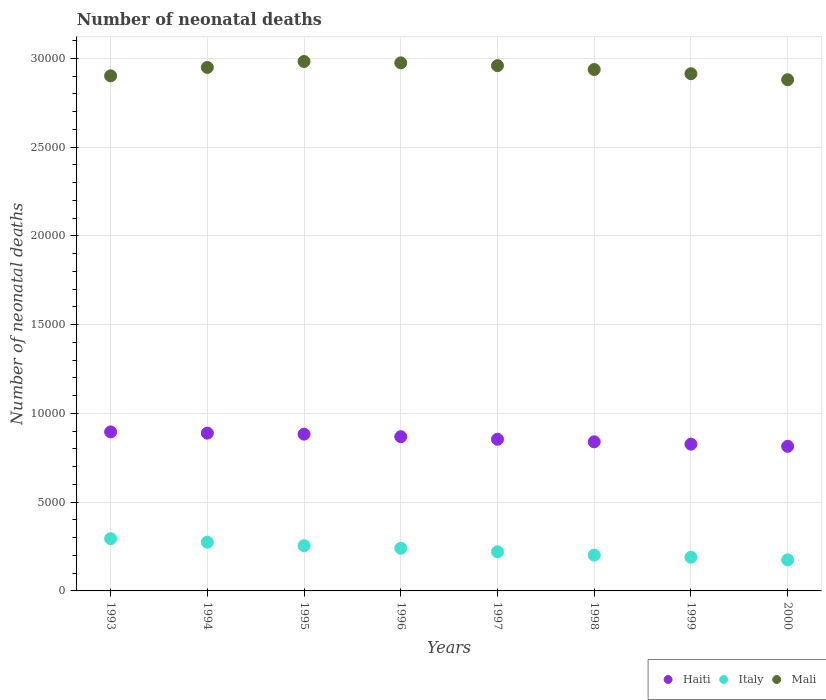How many different coloured dotlines are there?
Keep it short and to the point. 3. What is the number of neonatal deaths in in Haiti in 2000?
Provide a succinct answer. 8146. Across all years, what is the maximum number of neonatal deaths in in Mali?
Offer a terse response. 2.98e+04. Across all years, what is the minimum number of neonatal deaths in in Haiti?
Your answer should be compact. 8146. In which year was the number of neonatal deaths in in Italy maximum?
Offer a very short reply. 1993. What is the total number of neonatal deaths in in Mali in the graph?
Your answer should be compact. 2.35e+05. What is the difference between the number of neonatal deaths in in Mali in 1996 and that in 1998?
Provide a succinct answer. 376. What is the difference between the number of neonatal deaths in in Mali in 1993 and the number of neonatal deaths in in Italy in 1997?
Make the answer very short. 2.68e+04. What is the average number of neonatal deaths in in Haiti per year?
Provide a succinct answer. 8590.38. In the year 1998, what is the difference between the number of neonatal deaths in in Haiti and number of neonatal deaths in in Mali?
Give a very brief answer. -2.10e+04. In how many years, is the number of neonatal deaths in in Mali greater than 7000?
Offer a terse response. 8. What is the ratio of the number of neonatal deaths in in Haiti in 1993 to that in 2000?
Give a very brief answer. 1.1. What is the difference between the highest and the second highest number of neonatal deaths in in Haiti?
Your answer should be very brief. 70. What is the difference between the highest and the lowest number of neonatal deaths in in Haiti?
Provide a short and direct response. 812. Is the sum of the number of neonatal deaths in in Haiti in 1994 and 1996 greater than the maximum number of neonatal deaths in in Italy across all years?
Ensure brevity in your answer.  Yes. Is it the case that in every year, the sum of the number of neonatal deaths in in Mali and number of neonatal deaths in in Haiti  is greater than the number of neonatal deaths in in Italy?
Provide a succinct answer. Yes. Does the number of neonatal deaths in in Haiti monotonically increase over the years?
Provide a succinct answer. No. Is the number of neonatal deaths in in Italy strictly greater than the number of neonatal deaths in in Haiti over the years?
Your answer should be very brief. No. How many years are there in the graph?
Your answer should be compact. 8. Does the graph contain grids?
Your answer should be compact. Yes. How many legend labels are there?
Your answer should be very brief. 3. What is the title of the graph?
Offer a very short reply. Number of neonatal deaths. Does "Cambodia" appear as one of the legend labels in the graph?
Provide a succinct answer. No. What is the label or title of the X-axis?
Ensure brevity in your answer.  Years. What is the label or title of the Y-axis?
Give a very brief answer. Number of neonatal deaths. What is the Number of neonatal deaths of Haiti in 1993?
Your response must be concise. 8958. What is the Number of neonatal deaths in Italy in 1993?
Make the answer very short. 2942. What is the Number of neonatal deaths in Mali in 1993?
Give a very brief answer. 2.90e+04. What is the Number of neonatal deaths in Haiti in 1994?
Your answer should be compact. 8888. What is the Number of neonatal deaths of Italy in 1994?
Make the answer very short. 2745. What is the Number of neonatal deaths in Mali in 1994?
Your answer should be compact. 2.95e+04. What is the Number of neonatal deaths in Haiti in 1995?
Keep it short and to the point. 8831. What is the Number of neonatal deaths of Italy in 1995?
Ensure brevity in your answer.  2549. What is the Number of neonatal deaths of Mali in 1995?
Give a very brief answer. 2.98e+04. What is the Number of neonatal deaths in Haiti in 1996?
Provide a short and direct response. 8688. What is the Number of neonatal deaths of Italy in 1996?
Your answer should be very brief. 2403. What is the Number of neonatal deaths of Mali in 1996?
Give a very brief answer. 2.97e+04. What is the Number of neonatal deaths in Haiti in 1997?
Your response must be concise. 8544. What is the Number of neonatal deaths of Italy in 1997?
Your answer should be compact. 2205. What is the Number of neonatal deaths in Mali in 1997?
Your response must be concise. 2.96e+04. What is the Number of neonatal deaths of Haiti in 1998?
Ensure brevity in your answer.  8401. What is the Number of neonatal deaths in Italy in 1998?
Provide a succinct answer. 2016. What is the Number of neonatal deaths of Mali in 1998?
Provide a succinct answer. 2.94e+04. What is the Number of neonatal deaths of Haiti in 1999?
Keep it short and to the point. 8267. What is the Number of neonatal deaths in Italy in 1999?
Your answer should be very brief. 1898. What is the Number of neonatal deaths in Mali in 1999?
Provide a succinct answer. 2.91e+04. What is the Number of neonatal deaths in Haiti in 2000?
Your response must be concise. 8146. What is the Number of neonatal deaths of Italy in 2000?
Your answer should be compact. 1749. What is the Number of neonatal deaths in Mali in 2000?
Keep it short and to the point. 2.88e+04. Across all years, what is the maximum Number of neonatal deaths of Haiti?
Keep it short and to the point. 8958. Across all years, what is the maximum Number of neonatal deaths of Italy?
Keep it short and to the point. 2942. Across all years, what is the maximum Number of neonatal deaths of Mali?
Make the answer very short. 2.98e+04. Across all years, what is the minimum Number of neonatal deaths of Haiti?
Give a very brief answer. 8146. Across all years, what is the minimum Number of neonatal deaths of Italy?
Give a very brief answer. 1749. Across all years, what is the minimum Number of neonatal deaths of Mali?
Offer a very short reply. 2.88e+04. What is the total Number of neonatal deaths of Haiti in the graph?
Your response must be concise. 6.87e+04. What is the total Number of neonatal deaths in Italy in the graph?
Provide a short and direct response. 1.85e+04. What is the total Number of neonatal deaths in Mali in the graph?
Offer a very short reply. 2.35e+05. What is the difference between the Number of neonatal deaths of Italy in 1993 and that in 1994?
Provide a succinct answer. 197. What is the difference between the Number of neonatal deaths in Mali in 1993 and that in 1994?
Provide a succinct answer. -475. What is the difference between the Number of neonatal deaths in Haiti in 1993 and that in 1995?
Keep it short and to the point. 127. What is the difference between the Number of neonatal deaths in Italy in 1993 and that in 1995?
Make the answer very short. 393. What is the difference between the Number of neonatal deaths in Mali in 1993 and that in 1995?
Provide a short and direct response. -808. What is the difference between the Number of neonatal deaths in Haiti in 1993 and that in 1996?
Provide a short and direct response. 270. What is the difference between the Number of neonatal deaths of Italy in 1993 and that in 1996?
Give a very brief answer. 539. What is the difference between the Number of neonatal deaths in Mali in 1993 and that in 1996?
Your answer should be very brief. -731. What is the difference between the Number of neonatal deaths of Haiti in 1993 and that in 1997?
Provide a short and direct response. 414. What is the difference between the Number of neonatal deaths of Italy in 1993 and that in 1997?
Provide a succinct answer. 737. What is the difference between the Number of neonatal deaths in Mali in 1993 and that in 1997?
Keep it short and to the point. -574. What is the difference between the Number of neonatal deaths of Haiti in 1993 and that in 1998?
Provide a short and direct response. 557. What is the difference between the Number of neonatal deaths of Italy in 1993 and that in 1998?
Your answer should be compact. 926. What is the difference between the Number of neonatal deaths of Mali in 1993 and that in 1998?
Your response must be concise. -355. What is the difference between the Number of neonatal deaths of Haiti in 1993 and that in 1999?
Give a very brief answer. 691. What is the difference between the Number of neonatal deaths in Italy in 1993 and that in 1999?
Offer a very short reply. 1044. What is the difference between the Number of neonatal deaths in Mali in 1993 and that in 1999?
Provide a short and direct response. -120. What is the difference between the Number of neonatal deaths in Haiti in 1993 and that in 2000?
Your response must be concise. 812. What is the difference between the Number of neonatal deaths in Italy in 1993 and that in 2000?
Provide a succinct answer. 1193. What is the difference between the Number of neonatal deaths in Mali in 1993 and that in 2000?
Make the answer very short. 219. What is the difference between the Number of neonatal deaths in Italy in 1994 and that in 1995?
Make the answer very short. 196. What is the difference between the Number of neonatal deaths of Mali in 1994 and that in 1995?
Ensure brevity in your answer.  -333. What is the difference between the Number of neonatal deaths of Italy in 1994 and that in 1996?
Your answer should be very brief. 342. What is the difference between the Number of neonatal deaths of Mali in 1994 and that in 1996?
Your answer should be compact. -256. What is the difference between the Number of neonatal deaths of Haiti in 1994 and that in 1997?
Keep it short and to the point. 344. What is the difference between the Number of neonatal deaths of Italy in 1994 and that in 1997?
Keep it short and to the point. 540. What is the difference between the Number of neonatal deaths of Mali in 1994 and that in 1997?
Give a very brief answer. -99. What is the difference between the Number of neonatal deaths of Haiti in 1994 and that in 1998?
Keep it short and to the point. 487. What is the difference between the Number of neonatal deaths in Italy in 1994 and that in 1998?
Make the answer very short. 729. What is the difference between the Number of neonatal deaths of Mali in 1994 and that in 1998?
Your answer should be compact. 120. What is the difference between the Number of neonatal deaths in Haiti in 1994 and that in 1999?
Provide a succinct answer. 621. What is the difference between the Number of neonatal deaths in Italy in 1994 and that in 1999?
Provide a succinct answer. 847. What is the difference between the Number of neonatal deaths of Mali in 1994 and that in 1999?
Make the answer very short. 355. What is the difference between the Number of neonatal deaths in Haiti in 1994 and that in 2000?
Offer a very short reply. 742. What is the difference between the Number of neonatal deaths of Italy in 1994 and that in 2000?
Offer a terse response. 996. What is the difference between the Number of neonatal deaths in Mali in 1994 and that in 2000?
Offer a terse response. 694. What is the difference between the Number of neonatal deaths in Haiti in 1995 and that in 1996?
Give a very brief answer. 143. What is the difference between the Number of neonatal deaths in Italy in 1995 and that in 1996?
Offer a terse response. 146. What is the difference between the Number of neonatal deaths of Haiti in 1995 and that in 1997?
Your answer should be compact. 287. What is the difference between the Number of neonatal deaths of Italy in 1995 and that in 1997?
Offer a very short reply. 344. What is the difference between the Number of neonatal deaths in Mali in 1995 and that in 1997?
Ensure brevity in your answer.  234. What is the difference between the Number of neonatal deaths in Haiti in 1995 and that in 1998?
Your answer should be very brief. 430. What is the difference between the Number of neonatal deaths in Italy in 1995 and that in 1998?
Your answer should be compact. 533. What is the difference between the Number of neonatal deaths in Mali in 1995 and that in 1998?
Your response must be concise. 453. What is the difference between the Number of neonatal deaths of Haiti in 1995 and that in 1999?
Offer a very short reply. 564. What is the difference between the Number of neonatal deaths of Italy in 1995 and that in 1999?
Ensure brevity in your answer.  651. What is the difference between the Number of neonatal deaths of Mali in 1995 and that in 1999?
Make the answer very short. 688. What is the difference between the Number of neonatal deaths of Haiti in 1995 and that in 2000?
Your answer should be very brief. 685. What is the difference between the Number of neonatal deaths in Italy in 1995 and that in 2000?
Provide a short and direct response. 800. What is the difference between the Number of neonatal deaths in Mali in 1995 and that in 2000?
Make the answer very short. 1027. What is the difference between the Number of neonatal deaths in Haiti in 1996 and that in 1997?
Your response must be concise. 144. What is the difference between the Number of neonatal deaths in Italy in 1996 and that in 1997?
Your answer should be very brief. 198. What is the difference between the Number of neonatal deaths in Mali in 1996 and that in 1997?
Ensure brevity in your answer.  157. What is the difference between the Number of neonatal deaths in Haiti in 1996 and that in 1998?
Keep it short and to the point. 287. What is the difference between the Number of neonatal deaths in Italy in 1996 and that in 1998?
Make the answer very short. 387. What is the difference between the Number of neonatal deaths in Mali in 1996 and that in 1998?
Provide a succinct answer. 376. What is the difference between the Number of neonatal deaths of Haiti in 1996 and that in 1999?
Your answer should be very brief. 421. What is the difference between the Number of neonatal deaths in Italy in 1996 and that in 1999?
Give a very brief answer. 505. What is the difference between the Number of neonatal deaths in Mali in 1996 and that in 1999?
Your response must be concise. 611. What is the difference between the Number of neonatal deaths in Haiti in 1996 and that in 2000?
Keep it short and to the point. 542. What is the difference between the Number of neonatal deaths in Italy in 1996 and that in 2000?
Ensure brevity in your answer.  654. What is the difference between the Number of neonatal deaths in Mali in 1996 and that in 2000?
Your answer should be very brief. 950. What is the difference between the Number of neonatal deaths in Haiti in 1997 and that in 1998?
Your answer should be compact. 143. What is the difference between the Number of neonatal deaths in Italy in 1997 and that in 1998?
Provide a short and direct response. 189. What is the difference between the Number of neonatal deaths in Mali in 1997 and that in 1998?
Offer a very short reply. 219. What is the difference between the Number of neonatal deaths of Haiti in 1997 and that in 1999?
Your response must be concise. 277. What is the difference between the Number of neonatal deaths in Italy in 1997 and that in 1999?
Offer a terse response. 307. What is the difference between the Number of neonatal deaths in Mali in 1997 and that in 1999?
Your response must be concise. 454. What is the difference between the Number of neonatal deaths in Haiti in 1997 and that in 2000?
Your answer should be compact. 398. What is the difference between the Number of neonatal deaths in Italy in 1997 and that in 2000?
Provide a succinct answer. 456. What is the difference between the Number of neonatal deaths in Mali in 1997 and that in 2000?
Make the answer very short. 793. What is the difference between the Number of neonatal deaths in Haiti in 1998 and that in 1999?
Your answer should be compact. 134. What is the difference between the Number of neonatal deaths in Italy in 1998 and that in 1999?
Offer a terse response. 118. What is the difference between the Number of neonatal deaths of Mali in 1998 and that in 1999?
Your answer should be compact. 235. What is the difference between the Number of neonatal deaths of Haiti in 1998 and that in 2000?
Offer a terse response. 255. What is the difference between the Number of neonatal deaths of Italy in 1998 and that in 2000?
Give a very brief answer. 267. What is the difference between the Number of neonatal deaths in Mali in 1998 and that in 2000?
Ensure brevity in your answer.  574. What is the difference between the Number of neonatal deaths of Haiti in 1999 and that in 2000?
Your answer should be very brief. 121. What is the difference between the Number of neonatal deaths in Italy in 1999 and that in 2000?
Ensure brevity in your answer.  149. What is the difference between the Number of neonatal deaths in Mali in 1999 and that in 2000?
Provide a succinct answer. 339. What is the difference between the Number of neonatal deaths of Haiti in 1993 and the Number of neonatal deaths of Italy in 1994?
Ensure brevity in your answer.  6213. What is the difference between the Number of neonatal deaths in Haiti in 1993 and the Number of neonatal deaths in Mali in 1994?
Keep it short and to the point. -2.05e+04. What is the difference between the Number of neonatal deaths in Italy in 1993 and the Number of neonatal deaths in Mali in 1994?
Your answer should be compact. -2.65e+04. What is the difference between the Number of neonatal deaths of Haiti in 1993 and the Number of neonatal deaths of Italy in 1995?
Ensure brevity in your answer.  6409. What is the difference between the Number of neonatal deaths in Haiti in 1993 and the Number of neonatal deaths in Mali in 1995?
Give a very brief answer. -2.09e+04. What is the difference between the Number of neonatal deaths in Italy in 1993 and the Number of neonatal deaths in Mali in 1995?
Keep it short and to the point. -2.69e+04. What is the difference between the Number of neonatal deaths of Haiti in 1993 and the Number of neonatal deaths of Italy in 1996?
Your answer should be very brief. 6555. What is the difference between the Number of neonatal deaths in Haiti in 1993 and the Number of neonatal deaths in Mali in 1996?
Offer a terse response. -2.08e+04. What is the difference between the Number of neonatal deaths of Italy in 1993 and the Number of neonatal deaths of Mali in 1996?
Keep it short and to the point. -2.68e+04. What is the difference between the Number of neonatal deaths in Haiti in 1993 and the Number of neonatal deaths in Italy in 1997?
Ensure brevity in your answer.  6753. What is the difference between the Number of neonatal deaths of Haiti in 1993 and the Number of neonatal deaths of Mali in 1997?
Make the answer very short. -2.06e+04. What is the difference between the Number of neonatal deaths of Italy in 1993 and the Number of neonatal deaths of Mali in 1997?
Your response must be concise. -2.66e+04. What is the difference between the Number of neonatal deaths of Haiti in 1993 and the Number of neonatal deaths of Italy in 1998?
Make the answer very short. 6942. What is the difference between the Number of neonatal deaths in Haiti in 1993 and the Number of neonatal deaths in Mali in 1998?
Keep it short and to the point. -2.04e+04. What is the difference between the Number of neonatal deaths in Italy in 1993 and the Number of neonatal deaths in Mali in 1998?
Keep it short and to the point. -2.64e+04. What is the difference between the Number of neonatal deaths of Haiti in 1993 and the Number of neonatal deaths of Italy in 1999?
Your answer should be compact. 7060. What is the difference between the Number of neonatal deaths in Haiti in 1993 and the Number of neonatal deaths in Mali in 1999?
Make the answer very short. -2.02e+04. What is the difference between the Number of neonatal deaths of Italy in 1993 and the Number of neonatal deaths of Mali in 1999?
Your response must be concise. -2.62e+04. What is the difference between the Number of neonatal deaths in Haiti in 1993 and the Number of neonatal deaths in Italy in 2000?
Make the answer very short. 7209. What is the difference between the Number of neonatal deaths of Haiti in 1993 and the Number of neonatal deaths of Mali in 2000?
Your answer should be very brief. -1.98e+04. What is the difference between the Number of neonatal deaths in Italy in 1993 and the Number of neonatal deaths in Mali in 2000?
Offer a very short reply. -2.59e+04. What is the difference between the Number of neonatal deaths in Haiti in 1994 and the Number of neonatal deaths in Italy in 1995?
Your answer should be very brief. 6339. What is the difference between the Number of neonatal deaths of Haiti in 1994 and the Number of neonatal deaths of Mali in 1995?
Your answer should be very brief. -2.09e+04. What is the difference between the Number of neonatal deaths of Italy in 1994 and the Number of neonatal deaths of Mali in 1995?
Ensure brevity in your answer.  -2.71e+04. What is the difference between the Number of neonatal deaths of Haiti in 1994 and the Number of neonatal deaths of Italy in 1996?
Provide a succinct answer. 6485. What is the difference between the Number of neonatal deaths in Haiti in 1994 and the Number of neonatal deaths in Mali in 1996?
Keep it short and to the point. -2.09e+04. What is the difference between the Number of neonatal deaths of Italy in 1994 and the Number of neonatal deaths of Mali in 1996?
Provide a succinct answer. -2.70e+04. What is the difference between the Number of neonatal deaths in Haiti in 1994 and the Number of neonatal deaths in Italy in 1997?
Offer a terse response. 6683. What is the difference between the Number of neonatal deaths of Haiti in 1994 and the Number of neonatal deaths of Mali in 1997?
Provide a short and direct response. -2.07e+04. What is the difference between the Number of neonatal deaths in Italy in 1994 and the Number of neonatal deaths in Mali in 1997?
Your answer should be very brief. -2.68e+04. What is the difference between the Number of neonatal deaths in Haiti in 1994 and the Number of neonatal deaths in Italy in 1998?
Make the answer very short. 6872. What is the difference between the Number of neonatal deaths of Haiti in 1994 and the Number of neonatal deaths of Mali in 1998?
Your answer should be compact. -2.05e+04. What is the difference between the Number of neonatal deaths of Italy in 1994 and the Number of neonatal deaths of Mali in 1998?
Your response must be concise. -2.66e+04. What is the difference between the Number of neonatal deaths of Haiti in 1994 and the Number of neonatal deaths of Italy in 1999?
Offer a very short reply. 6990. What is the difference between the Number of neonatal deaths of Haiti in 1994 and the Number of neonatal deaths of Mali in 1999?
Your answer should be very brief. -2.02e+04. What is the difference between the Number of neonatal deaths of Italy in 1994 and the Number of neonatal deaths of Mali in 1999?
Your answer should be compact. -2.64e+04. What is the difference between the Number of neonatal deaths in Haiti in 1994 and the Number of neonatal deaths in Italy in 2000?
Offer a very short reply. 7139. What is the difference between the Number of neonatal deaths of Haiti in 1994 and the Number of neonatal deaths of Mali in 2000?
Ensure brevity in your answer.  -1.99e+04. What is the difference between the Number of neonatal deaths in Italy in 1994 and the Number of neonatal deaths in Mali in 2000?
Provide a short and direct response. -2.61e+04. What is the difference between the Number of neonatal deaths in Haiti in 1995 and the Number of neonatal deaths in Italy in 1996?
Ensure brevity in your answer.  6428. What is the difference between the Number of neonatal deaths of Haiti in 1995 and the Number of neonatal deaths of Mali in 1996?
Make the answer very short. -2.09e+04. What is the difference between the Number of neonatal deaths of Italy in 1995 and the Number of neonatal deaths of Mali in 1996?
Your response must be concise. -2.72e+04. What is the difference between the Number of neonatal deaths in Haiti in 1995 and the Number of neonatal deaths in Italy in 1997?
Ensure brevity in your answer.  6626. What is the difference between the Number of neonatal deaths of Haiti in 1995 and the Number of neonatal deaths of Mali in 1997?
Make the answer very short. -2.08e+04. What is the difference between the Number of neonatal deaths in Italy in 1995 and the Number of neonatal deaths in Mali in 1997?
Provide a succinct answer. -2.70e+04. What is the difference between the Number of neonatal deaths in Haiti in 1995 and the Number of neonatal deaths in Italy in 1998?
Your answer should be compact. 6815. What is the difference between the Number of neonatal deaths of Haiti in 1995 and the Number of neonatal deaths of Mali in 1998?
Provide a succinct answer. -2.05e+04. What is the difference between the Number of neonatal deaths of Italy in 1995 and the Number of neonatal deaths of Mali in 1998?
Your response must be concise. -2.68e+04. What is the difference between the Number of neonatal deaths in Haiti in 1995 and the Number of neonatal deaths in Italy in 1999?
Ensure brevity in your answer.  6933. What is the difference between the Number of neonatal deaths in Haiti in 1995 and the Number of neonatal deaths in Mali in 1999?
Keep it short and to the point. -2.03e+04. What is the difference between the Number of neonatal deaths of Italy in 1995 and the Number of neonatal deaths of Mali in 1999?
Your response must be concise. -2.66e+04. What is the difference between the Number of neonatal deaths in Haiti in 1995 and the Number of neonatal deaths in Italy in 2000?
Provide a short and direct response. 7082. What is the difference between the Number of neonatal deaths of Haiti in 1995 and the Number of neonatal deaths of Mali in 2000?
Your answer should be very brief. -2.00e+04. What is the difference between the Number of neonatal deaths in Italy in 1995 and the Number of neonatal deaths in Mali in 2000?
Give a very brief answer. -2.62e+04. What is the difference between the Number of neonatal deaths in Haiti in 1996 and the Number of neonatal deaths in Italy in 1997?
Your answer should be compact. 6483. What is the difference between the Number of neonatal deaths in Haiti in 1996 and the Number of neonatal deaths in Mali in 1997?
Offer a terse response. -2.09e+04. What is the difference between the Number of neonatal deaths in Italy in 1996 and the Number of neonatal deaths in Mali in 1997?
Keep it short and to the point. -2.72e+04. What is the difference between the Number of neonatal deaths of Haiti in 1996 and the Number of neonatal deaths of Italy in 1998?
Ensure brevity in your answer.  6672. What is the difference between the Number of neonatal deaths of Haiti in 1996 and the Number of neonatal deaths of Mali in 1998?
Offer a very short reply. -2.07e+04. What is the difference between the Number of neonatal deaths of Italy in 1996 and the Number of neonatal deaths of Mali in 1998?
Give a very brief answer. -2.70e+04. What is the difference between the Number of neonatal deaths of Haiti in 1996 and the Number of neonatal deaths of Italy in 1999?
Your response must be concise. 6790. What is the difference between the Number of neonatal deaths of Haiti in 1996 and the Number of neonatal deaths of Mali in 1999?
Your response must be concise. -2.04e+04. What is the difference between the Number of neonatal deaths of Italy in 1996 and the Number of neonatal deaths of Mali in 1999?
Ensure brevity in your answer.  -2.67e+04. What is the difference between the Number of neonatal deaths of Haiti in 1996 and the Number of neonatal deaths of Italy in 2000?
Provide a short and direct response. 6939. What is the difference between the Number of neonatal deaths of Haiti in 1996 and the Number of neonatal deaths of Mali in 2000?
Your answer should be very brief. -2.01e+04. What is the difference between the Number of neonatal deaths in Italy in 1996 and the Number of neonatal deaths in Mali in 2000?
Your answer should be compact. -2.64e+04. What is the difference between the Number of neonatal deaths in Haiti in 1997 and the Number of neonatal deaths in Italy in 1998?
Provide a short and direct response. 6528. What is the difference between the Number of neonatal deaths of Haiti in 1997 and the Number of neonatal deaths of Mali in 1998?
Your answer should be very brief. -2.08e+04. What is the difference between the Number of neonatal deaths of Italy in 1997 and the Number of neonatal deaths of Mali in 1998?
Your answer should be compact. -2.72e+04. What is the difference between the Number of neonatal deaths in Haiti in 1997 and the Number of neonatal deaths in Italy in 1999?
Offer a terse response. 6646. What is the difference between the Number of neonatal deaths of Haiti in 1997 and the Number of neonatal deaths of Mali in 1999?
Provide a succinct answer. -2.06e+04. What is the difference between the Number of neonatal deaths of Italy in 1997 and the Number of neonatal deaths of Mali in 1999?
Offer a very short reply. -2.69e+04. What is the difference between the Number of neonatal deaths in Haiti in 1997 and the Number of neonatal deaths in Italy in 2000?
Offer a very short reply. 6795. What is the difference between the Number of neonatal deaths in Haiti in 1997 and the Number of neonatal deaths in Mali in 2000?
Offer a terse response. -2.03e+04. What is the difference between the Number of neonatal deaths of Italy in 1997 and the Number of neonatal deaths of Mali in 2000?
Your answer should be very brief. -2.66e+04. What is the difference between the Number of neonatal deaths in Haiti in 1998 and the Number of neonatal deaths in Italy in 1999?
Ensure brevity in your answer.  6503. What is the difference between the Number of neonatal deaths in Haiti in 1998 and the Number of neonatal deaths in Mali in 1999?
Provide a succinct answer. -2.07e+04. What is the difference between the Number of neonatal deaths of Italy in 1998 and the Number of neonatal deaths of Mali in 1999?
Give a very brief answer. -2.71e+04. What is the difference between the Number of neonatal deaths of Haiti in 1998 and the Number of neonatal deaths of Italy in 2000?
Make the answer very short. 6652. What is the difference between the Number of neonatal deaths of Haiti in 1998 and the Number of neonatal deaths of Mali in 2000?
Your answer should be very brief. -2.04e+04. What is the difference between the Number of neonatal deaths in Italy in 1998 and the Number of neonatal deaths in Mali in 2000?
Your response must be concise. -2.68e+04. What is the difference between the Number of neonatal deaths of Haiti in 1999 and the Number of neonatal deaths of Italy in 2000?
Give a very brief answer. 6518. What is the difference between the Number of neonatal deaths of Haiti in 1999 and the Number of neonatal deaths of Mali in 2000?
Provide a short and direct response. -2.05e+04. What is the difference between the Number of neonatal deaths in Italy in 1999 and the Number of neonatal deaths in Mali in 2000?
Provide a short and direct response. -2.69e+04. What is the average Number of neonatal deaths in Haiti per year?
Offer a very short reply. 8590.38. What is the average Number of neonatal deaths of Italy per year?
Give a very brief answer. 2313.38. What is the average Number of neonatal deaths of Mali per year?
Your response must be concise. 2.94e+04. In the year 1993, what is the difference between the Number of neonatal deaths of Haiti and Number of neonatal deaths of Italy?
Your answer should be very brief. 6016. In the year 1993, what is the difference between the Number of neonatal deaths of Haiti and Number of neonatal deaths of Mali?
Keep it short and to the point. -2.01e+04. In the year 1993, what is the difference between the Number of neonatal deaths of Italy and Number of neonatal deaths of Mali?
Keep it short and to the point. -2.61e+04. In the year 1994, what is the difference between the Number of neonatal deaths of Haiti and Number of neonatal deaths of Italy?
Offer a very short reply. 6143. In the year 1994, what is the difference between the Number of neonatal deaths of Haiti and Number of neonatal deaths of Mali?
Give a very brief answer. -2.06e+04. In the year 1994, what is the difference between the Number of neonatal deaths of Italy and Number of neonatal deaths of Mali?
Your answer should be very brief. -2.67e+04. In the year 1995, what is the difference between the Number of neonatal deaths of Haiti and Number of neonatal deaths of Italy?
Your answer should be very brief. 6282. In the year 1995, what is the difference between the Number of neonatal deaths in Haiti and Number of neonatal deaths in Mali?
Keep it short and to the point. -2.10e+04. In the year 1995, what is the difference between the Number of neonatal deaths in Italy and Number of neonatal deaths in Mali?
Your answer should be compact. -2.73e+04. In the year 1996, what is the difference between the Number of neonatal deaths of Haiti and Number of neonatal deaths of Italy?
Offer a terse response. 6285. In the year 1996, what is the difference between the Number of neonatal deaths of Haiti and Number of neonatal deaths of Mali?
Offer a terse response. -2.11e+04. In the year 1996, what is the difference between the Number of neonatal deaths of Italy and Number of neonatal deaths of Mali?
Give a very brief answer. -2.73e+04. In the year 1997, what is the difference between the Number of neonatal deaths of Haiti and Number of neonatal deaths of Italy?
Provide a succinct answer. 6339. In the year 1997, what is the difference between the Number of neonatal deaths of Haiti and Number of neonatal deaths of Mali?
Ensure brevity in your answer.  -2.10e+04. In the year 1997, what is the difference between the Number of neonatal deaths in Italy and Number of neonatal deaths in Mali?
Keep it short and to the point. -2.74e+04. In the year 1998, what is the difference between the Number of neonatal deaths in Haiti and Number of neonatal deaths in Italy?
Keep it short and to the point. 6385. In the year 1998, what is the difference between the Number of neonatal deaths of Haiti and Number of neonatal deaths of Mali?
Offer a terse response. -2.10e+04. In the year 1998, what is the difference between the Number of neonatal deaths of Italy and Number of neonatal deaths of Mali?
Give a very brief answer. -2.74e+04. In the year 1999, what is the difference between the Number of neonatal deaths of Haiti and Number of neonatal deaths of Italy?
Your response must be concise. 6369. In the year 1999, what is the difference between the Number of neonatal deaths in Haiti and Number of neonatal deaths in Mali?
Your answer should be compact. -2.09e+04. In the year 1999, what is the difference between the Number of neonatal deaths of Italy and Number of neonatal deaths of Mali?
Ensure brevity in your answer.  -2.72e+04. In the year 2000, what is the difference between the Number of neonatal deaths in Haiti and Number of neonatal deaths in Italy?
Your answer should be compact. 6397. In the year 2000, what is the difference between the Number of neonatal deaths in Haiti and Number of neonatal deaths in Mali?
Your answer should be very brief. -2.06e+04. In the year 2000, what is the difference between the Number of neonatal deaths of Italy and Number of neonatal deaths of Mali?
Give a very brief answer. -2.70e+04. What is the ratio of the Number of neonatal deaths in Haiti in 1993 to that in 1994?
Keep it short and to the point. 1.01. What is the ratio of the Number of neonatal deaths of Italy in 1993 to that in 1994?
Provide a short and direct response. 1.07. What is the ratio of the Number of neonatal deaths in Mali in 1993 to that in 1994?
Offer a very short reply. 0.98. What is the ratio of the Number of neonatal deaths of Haiti in 1993 to that in 1995?
Your response must be concise. 1.01. What is the ratio of the Number of neonatal deaths of Italy in 1993 to that in 1995?
Offer a terse response. 1.15. What is the ratio of the Number of neonatal deaths of Mali in 1993 to that in 1995?
Provide a succinct answer. 0.97. What is the ratio of the Number of neonatal deaths of Haiti in 1993 to that in 1996?
Your response must be concise. 1.03. What is the ratio of the Number of neonatal deaths of Italy in 1993 to that in 1996?
Your answer should be very brief. 1.22. What is the ratio of the Number of neonatal deaths of Mali in 1993 to that in 1996?
Provide a short and direct response. 0.98. What is the ratio of the Number of neonatal deaths of Haiti in 1993 to that in 1997?
Provide a succinct answer. 1.05. What is the ratio of the Number of neonatal deaths in Italy in 1993 to that in 1997?
Your response must be concise. 1.33. What is the ratio of the Number of neonatal deaths in Mali in 1993 to that in 1997?
Give a very brief answer. 0.98. What is the ratio of the Number of neonatal deaths in Haiti in 1993 to that in 1998?
Make the answer very short. 1.07. What is the ratio of the Number of neonatal deaths in Italy in 1993 to that in 1998?
Your answer should be compact. 1.46. What is the ratio of the Number of neonatal deaths of Mali in 1993 to that in 1998?
Your answer should be compact. 0.99. What is the ratio of the Number of neonatal deaths in Haiti in 1993 to that in 1999?
Offer a very short reply. 1.08. What is the ratio of the Number of neonatal deaths in Italy in 1993 to that in 1999?
Provide a short and direct response. 1.55. What is the ratio of the Number of neonatal deaths of Haiti in 1993 to that in 2000?
Provide a succinct answer. 1.1. What is the ratio of the Number of neonatal deaths of Italy in 1993 to that in 2000?
Ensure brevity in your answer.  1.68. What is the ratio of the Number of neonatal deaths in Mali in 1993 to that in 2000?
Your answer should be compact. 1.01. What is the ratio of the Number of neonatal deaths of Italy in 1994 to that in 1995?
Provide a succinct answer. 1.08. What is the ratio of the Number of neonatal deaths in Italy in 1994 to that in 1996?
Offer a very short reply. 1.14. What is the ratio of the Number of neonatal deaths of Mali in 1994 to that in 1996?
Your response must be concise. 0.99. What is the ratio of the Number of neonatal deaths of Haiti in 1994 to that in 1997?
Provide a succinct answer. 1.04. What is the ratio of the Number of neonatal deaths of Italy in 1994 to that in 1997?
Provide a short and direct response. 1.24. What is the ratio of the Number of neonatal deaths of Mali in 1994 to that in 1997?
Your response must be concise. 1. What is the ratio of the Number of neonatal deaths of Haiti in 1994 to that in 1998?
Give a very brief answer. 1.06. What is the ratio of the Number of neonatal deaths in Italy in 1994 to that in 1998?
Offer a very short reply. 1.36. What is the ratio of the Number of neonatal deaths in Haiti in 1994 to that in 1999?
Your answer should be very brief. 1.08. What is the ratio of the Number of neonatal deaths of Italy in 1994 to that in 1999?
Keep it short and to the point. 1.45. What is the ratio of the Number of neonatal deaths in Mali in 1994 to that in 1999?
Ensure brevity in your answer.  1.01. What is the ratio of the Number of neonatal deaths of Haiti in 1994 to that in 2000?
Ensure brevity in your answer.  1.09. What is the ratio of the Number of neonatal deaths in Italy in 1994 to that in 2000?
Ensure brevity in your answer.  1.57. What is the ratio of the Number of neonatal deaths in Mali in 1994 to that in 2000?
Provide a succinct answer. 1.02. What is the ratio of the Number of neonatal deaths in Haiti in 1995 to that in 1996?
Offer a very short reply. 1.02. What is the ratio of the Number of neonatal deaths of Italy in 1995 to that in 1996?
Provide a succinct answer. 1.06. What is the ratio of the Number of neonatal deaths in Haiti in 1995 to that in 1997?
Your answer should be very brief. 1.03. What is the ratio of the Number of neonatal deaths in Italy in 1995 to that in 1997?
Provide a short and direct response. 1.16. What is the ratio of the Number of neonatal deaths in Mali in 1995 to that in 1997?
Give a very brief answer. 1.01. What is the ratio of the Number of neonatal deaths of Haiti in 1995 to that in 1998?
Offer a very short reply. 1.05. What is the ratio of the Number of neonatal deaths in Italy in 1995 to that in 1998?
Your answer should be very brief. 1.26. What is the ratio of the Number of neonatal deaths of Mali in 1995 to that in 1998?
Your answer should be very brief. 1.02. What is the ratio of the Number of neonatal deaths in Haiti in 1995 to that in 1999?
Keep it short and to the point. 1.07. What is the ratio of the Number of neonatal deaths of Italy in 1995 to that in 1999?
Give a very brief answer. 1.34. What is the ratio of the Number of neonatal deaths of Mali in 1995 to that in 1999?
Give a very brief answer. 1.02. What is the ratio of the Number of neonatal deaths in Haiti in 1995 to that in 2000?
Your response must be concise. 1.08. What is the ratio of the Number of neonatal deaths in Italy in 1995 to that in 2000?
Make the answer very short. 1.46. What is the ratio of the Number of neonatal deaths in Mali in 1995 to that in 2000?
Your answer should be very brief. 1.04. What is the ratio of the Number of neonatal deaths of Haiti in 1996 to that in 1997?
Provide a succinct answer. 1.02. What is the ratio of the Number of neonatal deaths of Italy in 1996 to that in 1997?
Offer a very short reply. 1.09. What is the ratio of the Number of neonatal deaths of Mali in 1996 to that in 1997?
Offer a very short reply. 1.01. What is the ratio of the Number of neonatal deaths in Haiti in 1996 to that in 1998?
Provide a short and direct response. 1.03. What is the ratio of the Number of neonatal deaths in Italy in 1996 to that in 1998?
Give a very brief answer. 1.19. What is the ratio of the Number of neonatal deaths of Mali in 1996 to that in 1998?
Your answer should be very brief. 1.01. What is the ratio of the Number of neonatal deaths in Haiti in 1996 to that in 1999?
Keep it short and to the point. 1.05. What is the ratio of the Number of neonatal deaths in Italy in 1996 to that in 1999?
Offer a very short reply. 1.27. What is the ratio of the Number of neonatal deaths of Mali in 1996 to that in 1999?
Your answer should be very brief. 1.02. What is the ratio of the Number of neonatal deaths in Haiti in 1996 to that in 2000?
Keep it short and to the point. 1.07. What is the ratio of the Number of neonatal deaths in Italy in 1996 to that in 2000?
Make the answer very short. 1.37. What is the ratio of the Number of neonatal deaths of Mali in 1996 to that in 2000?
Ensure brevity in your answer.  1.03. What is the ratio of the Number of neonatal deaths of Haiti in 1997 to that in 1998?
Make the answer very short. 1.02. What is the ratio of the Number of neonatal deaths in Italy in 1997 to that in 1998?
Give a very brief answer. 1.09. What is the ratio of the Number of neonatal deaths in Mali in 1997 to that in 1998?
Your answer should be compact. 1.01. What is the ratio of the Number of neonatal deaths in Haiti in 1997 to that in 1999?
Keep it short and to the point. 1.03. What is the ratio of the Number of neonatal deaths in Italy in 1997 to that in 1999?
Offer a terse response. 1.16. What is the ratio of the Number of neonatal deaths of Mali in 1997 to that in 1999?
Provide a succinct answer. 1.02. What is the ratio of the Number of neonatal deaths of Haiti in 1997 to that in 2000?
Provide a short and direct response. 1.05. What is the ratio of the Number of neonatal deaths of Italy in 1997 to that in 2000?
Your answer should be compact. 1.26. What is the ratio of the Number of neonatal deaths of Mali in 1997 to that in 2000?
Your answer should be very brief. 1.03. What is the ratio of the Number of neonatal deaths in Haiti in 1998 to that in 1999?
Your answer should be compact. 1.02. What is the ratio of the Number of neonatal deaths of Italy in 1998 to that in 1999?
Offer a very short reply. 1.06. What is the ratio of the Number of neonatal deaths of Mali in 1998 to that in 1999?
Keep it short and to the point. 1.01. What is the ratio of the Number of neonatal deaths of Haiti in 1998 to that in 2000?
Provide a succinct answer. 1.03. What is the ratio of the Number of neonatal deaths of Italy in 1998 to that in 2000?
Provide a short and direct response. 1.15. What is the ratio of the Number of neonatal deaths of Mali in 1998 to that in 2000?
Make the answer very short. 1.02. What is the ratio of the Number of neonatal deaths of Haiti in 1999 to that in 2000?
Make the answer very short. 1.01. What is the ratio of the Number of neonatal deaths in Italy in 1999 to that in 2000?
Offer a terse response. 1.09. What is the ratio of the Number of neonatal deaths in Mali in 1999 to that in 2000?
Make the answer very short. 1.01. What is the difference between the highest and the second highest Number of neonatal deaths in Italy?
Offer a terse response. 197. What is the difference between the highest and the lowest Number of neonatal deaths in Haiti?
Provide a short and direct response. 812. What is the difference between the highest and the lowest Number of neonatal deaths of Italy?
Give a very brief answer. 1193. What is the difference between the highest and the lowest Number of neonatal deaths of Mali?
Ensure brevity in your answer.  1027. 